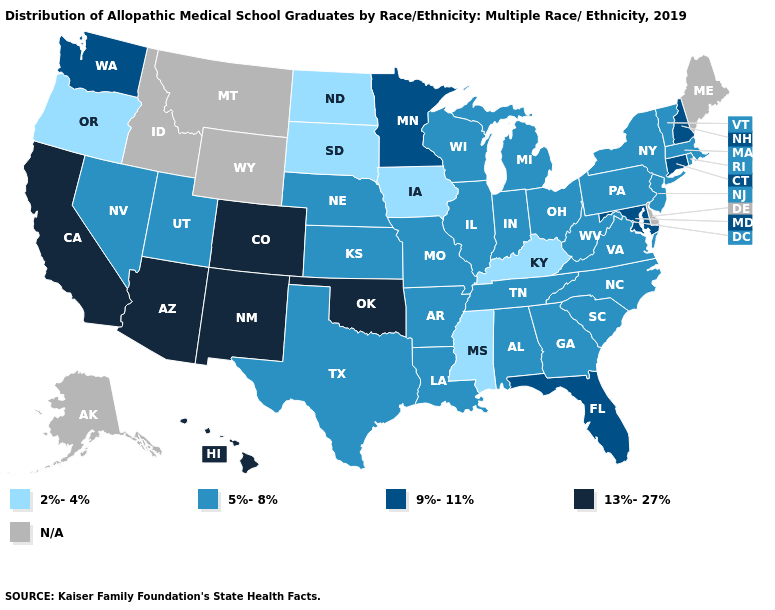What is the value of New York?
Quick response, please. 5%-8%. Name the states that have a value in the range 13%-27%?
Keep it brief. Arizona, California, Colorado, Hawaii, New Mexico, Oklahoma. Name the states that have a value in the range 2%-4%?
Short answer required. Iowa, Kentucky, Mississippi, North Dakota, Oregon, South Dakota. What is the value of New York?
Short answer required. 5%-8%. What is the value of Missouri?
Concise answer only. 5%-8%. Among the states that border Wisconsin , does Illinois have the highest value?
Keep it brief. No. What is the lowest value in the USA?
Write a very short answer. 2%-4%. Does Wisconsin have the lowest value in the MidWest?
Concise answer only. No. What is the lowest value in the South?
Concise answer only. 2%-4%. Name the states that have a value in the range 9%-11%?
Short answer required. Connecticut, Florida, Maryland, Minnesota, New Hampshire, Washington. What is the value of New York?
Answer briefly. 5%-8%. Name the states that have a value in the range 2%-4%?
Answer briefly. Iowa, Kentucky, Mississippi, North Dakota, Oregon, South Dakota. 